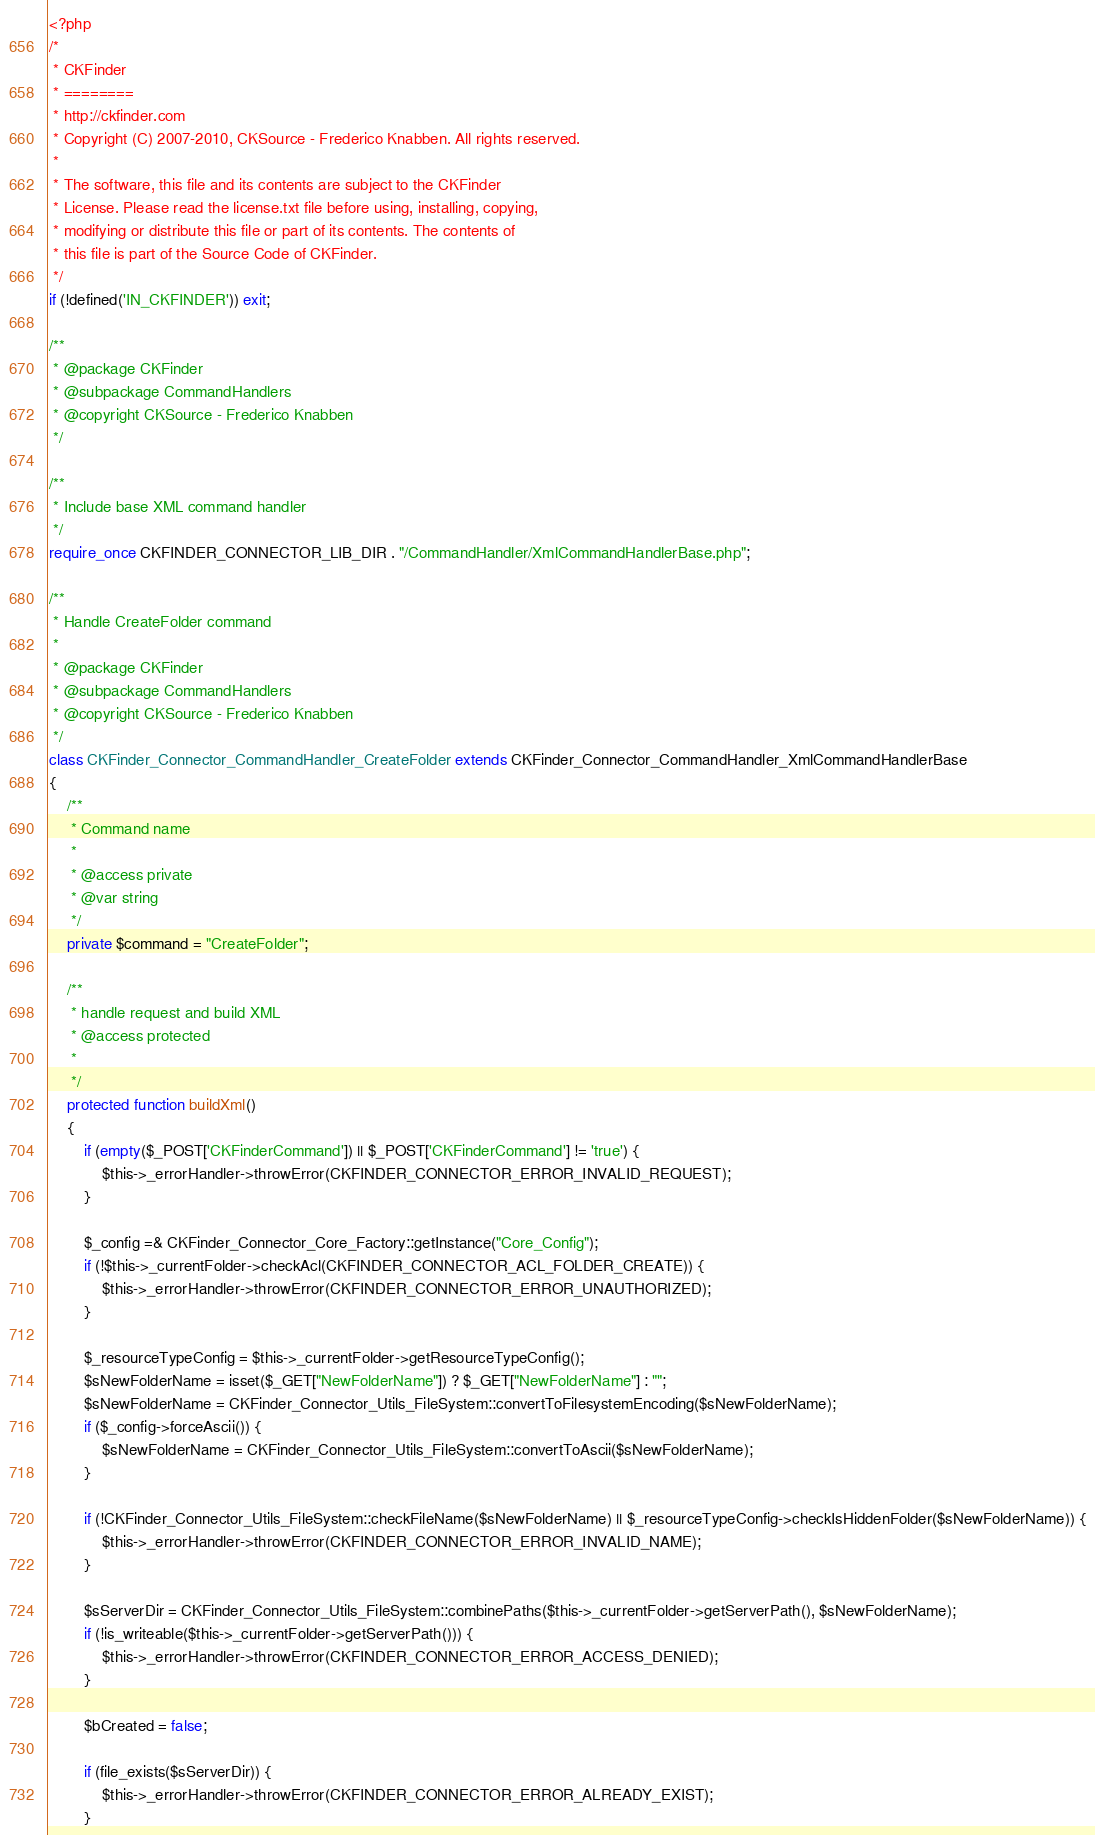Convert code to text. <code><loc_0><loc_0><loc_500><loc_500><_PHP_><?php
/*
 * CKFinder
 * ========
 * http://ckfinder.com
 * Copyright (C) 2007-2010, CKSource - Frederico Knabben. All rights reserved.
 *
 * The software, this file and its contents are subject to the CKFinder
 * License. Please read the license.txt file before using, installing, copying,
 * modifying or distribute this file or part of its contents. The contents of
 * this file is part of the Source Code of CKFinder.
 */
if (!defined('IN_CKFINDER')) exit;

/**
 * @package CKFinder
 * @subpackage CommandHandlers
 * @copyright CKSource - Frederico Knabben
 */

/**
 * Include base XML command handler
 */
require_once CKFINDER_CONNECTOR_LIB_DIR . "/CommandHandler/XmlCommandHandlerBase.php";

/**
 * Handle CreateFolder command
 *
 * @package CKFinder
 * @subpackage CommandHandlers
 * @copyright CKSource - Frederico Knabben
 */
class CKFinder_Connector_CommandHandler_CreateFolder extends CKFinder_Connector_CommandHandler_XmlCommandHandlerBase
{
    /**
     * Command name
     *
     * @access private
     * @var string
     */
    private $command = "CreateFolder";

    /**
     * handle request and build XML
     * @access protected
     *
     */
    protected function buildXml()
    {
        if (empty($_POST['CKFinderCommand']) || $_POST['CKFinderCommand'] != 'true') {
            $this->_errorHandler->throwError(CKFINDER_CONNECTOR_ERROR_INVALID_REQUEST);
        }

        $_config =& CKFinder_Connector_Core_Factory::getInstance("Core_Config");
        if (!$this->_currentFolder->checkAcl(CKFINDER_CONNECTOR_ACL_FOLDER_CREATE)) {
            $this->_errorHandler->throwError(CKFINDER_CONNECTOR_ERROR_UNAUTHORIZED);
        }

        $_resourceTypeConfig = $this->_currentFolder->getResourceTypeConfig();
        $sNewFolderName = isset($_GET["NewFolderName"]) ? $_GET["NewFolderName"] : "";
        $sNewFolderName = CKFinder_Connector_Utils_FileSystem::convertToFilesystemEncoding($sNewFolderName);
        if ($_config->forceAscii()) {
            $sNewFolderName = CKFinder_Connector_Utils_FileSystem::convertToAscii($sNewFolderName);
        }

        if (!CKFinder_Connector_Utils_FileSystem::checkFileName($sNewFolderName) || $_resourceTypeConfig->checkIsHiddenFolder($sNewFolderName)) {
            $this->_errorHandler->throwError(CKFINDER_CONNECTOR_ERROR_INVALID_NAME);
        }

        $sServerDir = CKFinder_Connector_Utils_FileSystem::combinePaths($this->_currentFolder->getServerPath(), $sNewFolderName);
        if (!is_writeable($this->_currentFolder->getServerPath())) {
            $this->_errorHandler->throwError(CKFINDER_CONNECTOR_ERROR_ACCESS_DENIED);
        }

        $bCreated = false;

        if (file_exists($sServerDir)) {
            $this->_errorHandler->throwError(CKFINDER_CONNECTOR_ERROR_ALREADY_EXIST);
        }
</code> 